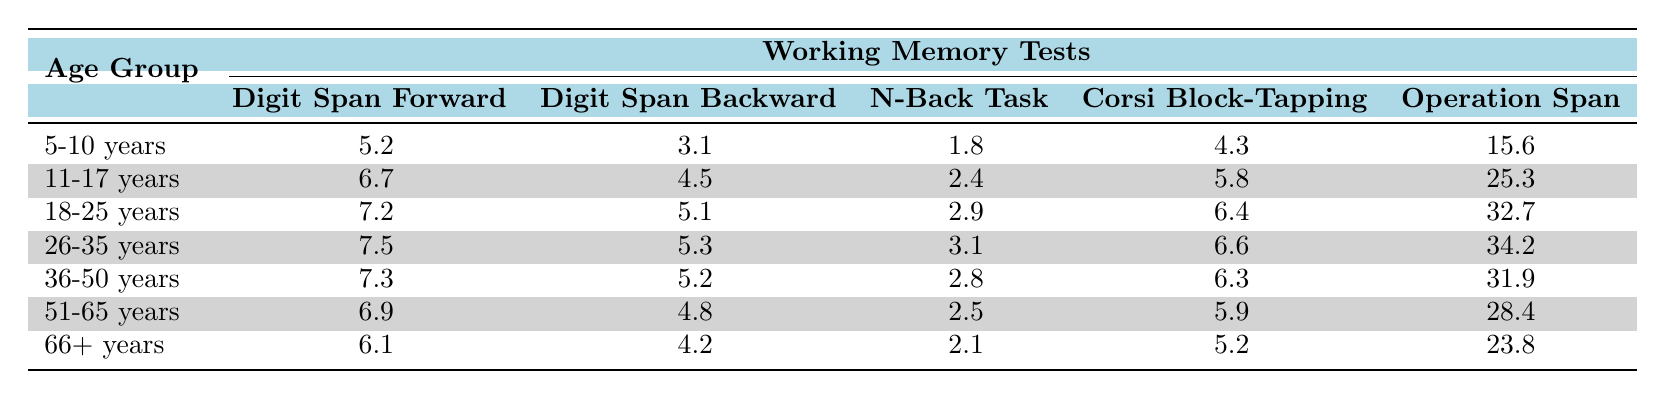What is the working memory capacity in the Digit Span Forward task for the 18-25 years age group? The table shows the working memory capacity for the Digit Span Forward task in the 18-25 years age group is 7.2.
Answer: 7.2 Which age group has the highest score in the Operation Span Task? From the table, the age group 26-35 years has the highest score in the Operation Span Task, which is 34.2.
Answer: 26-35 years What is the difference between the Digit Span Backward scores of the 5-10 years and 66+ years age groups? The Digit Span Backward score for the 5-10 years age group is 3.1 and for the 66+ years age group is 4.2. The difference is 4.2 - 3.1 = 1.1.
Answer: 1.1 Is there a general trend of increasing scores in the N-Back Task as the age increases? By examining the N-Back Task scores, we can see the values: 1.8, 2.4, 2.9, 3.1, 2.8, 2.5, and 2.1. The scores increase until the 26-35 years age group but decline afterward, suggesting there isn't a consistent increase across age groups.
Answer: No What is the average score for the Corsi Block-Tapping Test across all age groups? To find the average, sum the scores (4.3 + 5.8 + 6.4 + 6.6 + 6.3 + 5.9 + 5.2 = 40.6) and divide by the number of age groups (7). Therefore, the average is 40.6 / 7 = 5.8.
Answer: 5.8 Which age group scores the lowest in the N-Back Task? Looking at the N-Back Task scores in the table, the 5-10 years age group's score is the lowest at 1.8.
Answer: 5-10 years What can be inferred about the working memory capacity from the scores in the Digit Span Forward and Digit Span Backward tasks across all age groups? Upon examining the scores, it is clear that older age groups generally have higher scores in both tasks. The lowest scores are found in the younger age group (5-10 years), and the scores increase with age before plateauing or slightly declining in older groups.
Answer: Older age groups generally have higher scores What is the total score for the Operation Span Task across all age groups? The total score is found by adding the Operation Span Task scores: 15.6 + 25.3 + 32.7 + 34.2 + 31.9 + 28.4 + 23.8 = 191.9.
Answer: 191.9 How do the scores for the Digit Span Forward change from the 11-17 years age group to the 36-50 years age group? The scores are 6.7 for 11-17 years and 7.3 for 36-50 years. To determine the change, we calculate 7.3 - 6.7 = 0.6, indicating an increase in scores across these age groups.
Answer: Increase of 0.6 